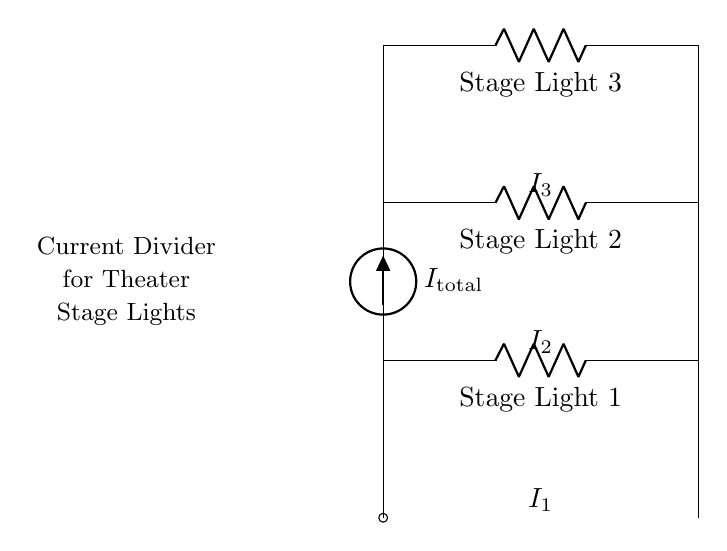What is the total current supplied to the circuit? The total current supplied to the circuit is labeled as I_total. It is the sum of the currents flowing through each of the three stage lights connected in parallel.
Answer: I_total How many stage lights are in the circuit? There are three stage lights in the circuit, as indicated by the three resistors labeled R1, R2, and R3, each representing a stage light.
Answer: Three What does R1 represent in the circuit? R1 represents Stage Light 1, as indicated by the label next to the resistor symbol. This is one of the components in the current divider used for controlling lighting.
Answer: Stage Light 1 If the total current is 6 Amperes, and the resistances are equal, what is the current through each light? In a current divider with equal resistances, the total current divides equally among the parallel components. Therefore, if the total current is 6 Amperes and there are three equal resistances, each current I1, I2, and I3 would be 6 Amperes divided by 3.
Answer: 2 Amperes Which component would have the largest current flow if their resistances were unequal? The component with the smallest resistance would have the largest current flow due to the inverse relationship between current and resistance in a parallel circuit, as defined by Ohm's law.
Answer: The smallest resistance What is the purpose of this current divider circuit? The purpose of this current divider circuit is to control the brightness of multiple stage lights simultaneously by splitting the total current to each light.
Answer: To dim stage lights 